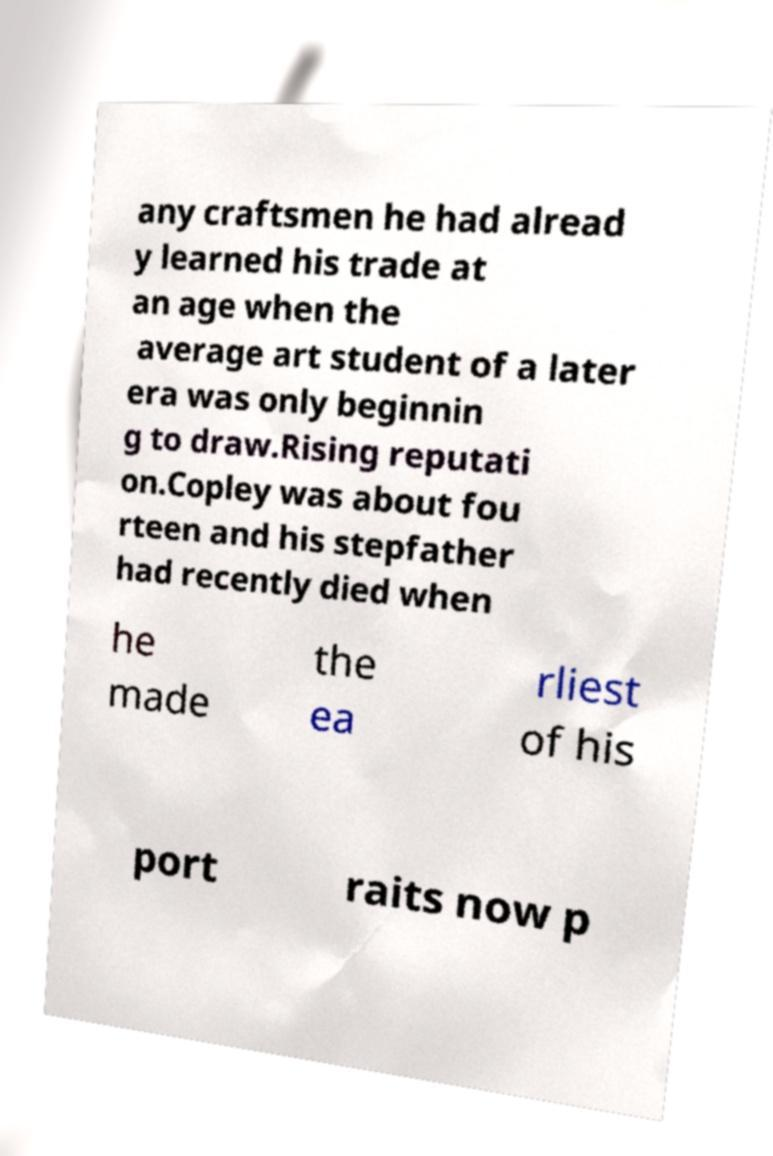For documentation purposes, I need the text within this image transcribed. Could you provide that? any craftsmen he had alread y learned his trade at an age when the average art student of a later era was only beginnin g to draw.Rising reputati on.Copley was about fou rteen and his stepfather had recently died when he made the ea rliest of his port raits now p 